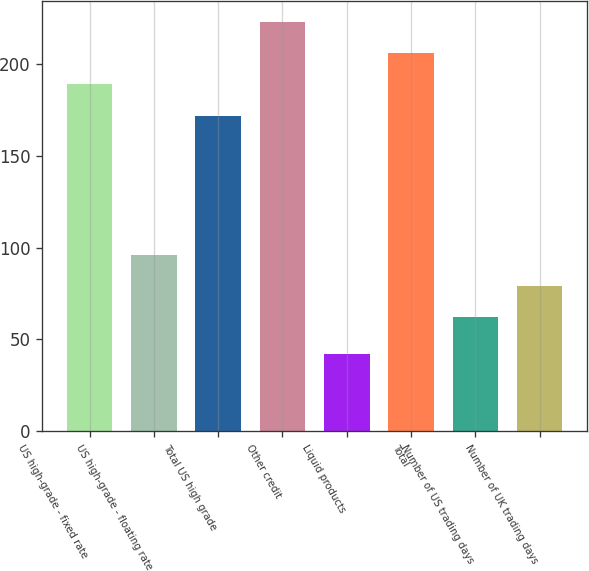Convert chart. <chart><loc_0><loc_0><loc_500><loc_500><bar_chart><fcel>US high-grade - fixed rate<fcel>US high-grade - floating rate<fcel>Total US high grade<fcel>Other credit<fcel>Liquid products<fcel>Total<fcel>Number of US trading days<fcel>Number of UK trading days<nl><fcel>189.1<fcel>96.2<fcel>172<fcel>223.3<fcel>42<fcel>206.2<fcel>62<fcel>79.1<nl></chart> 